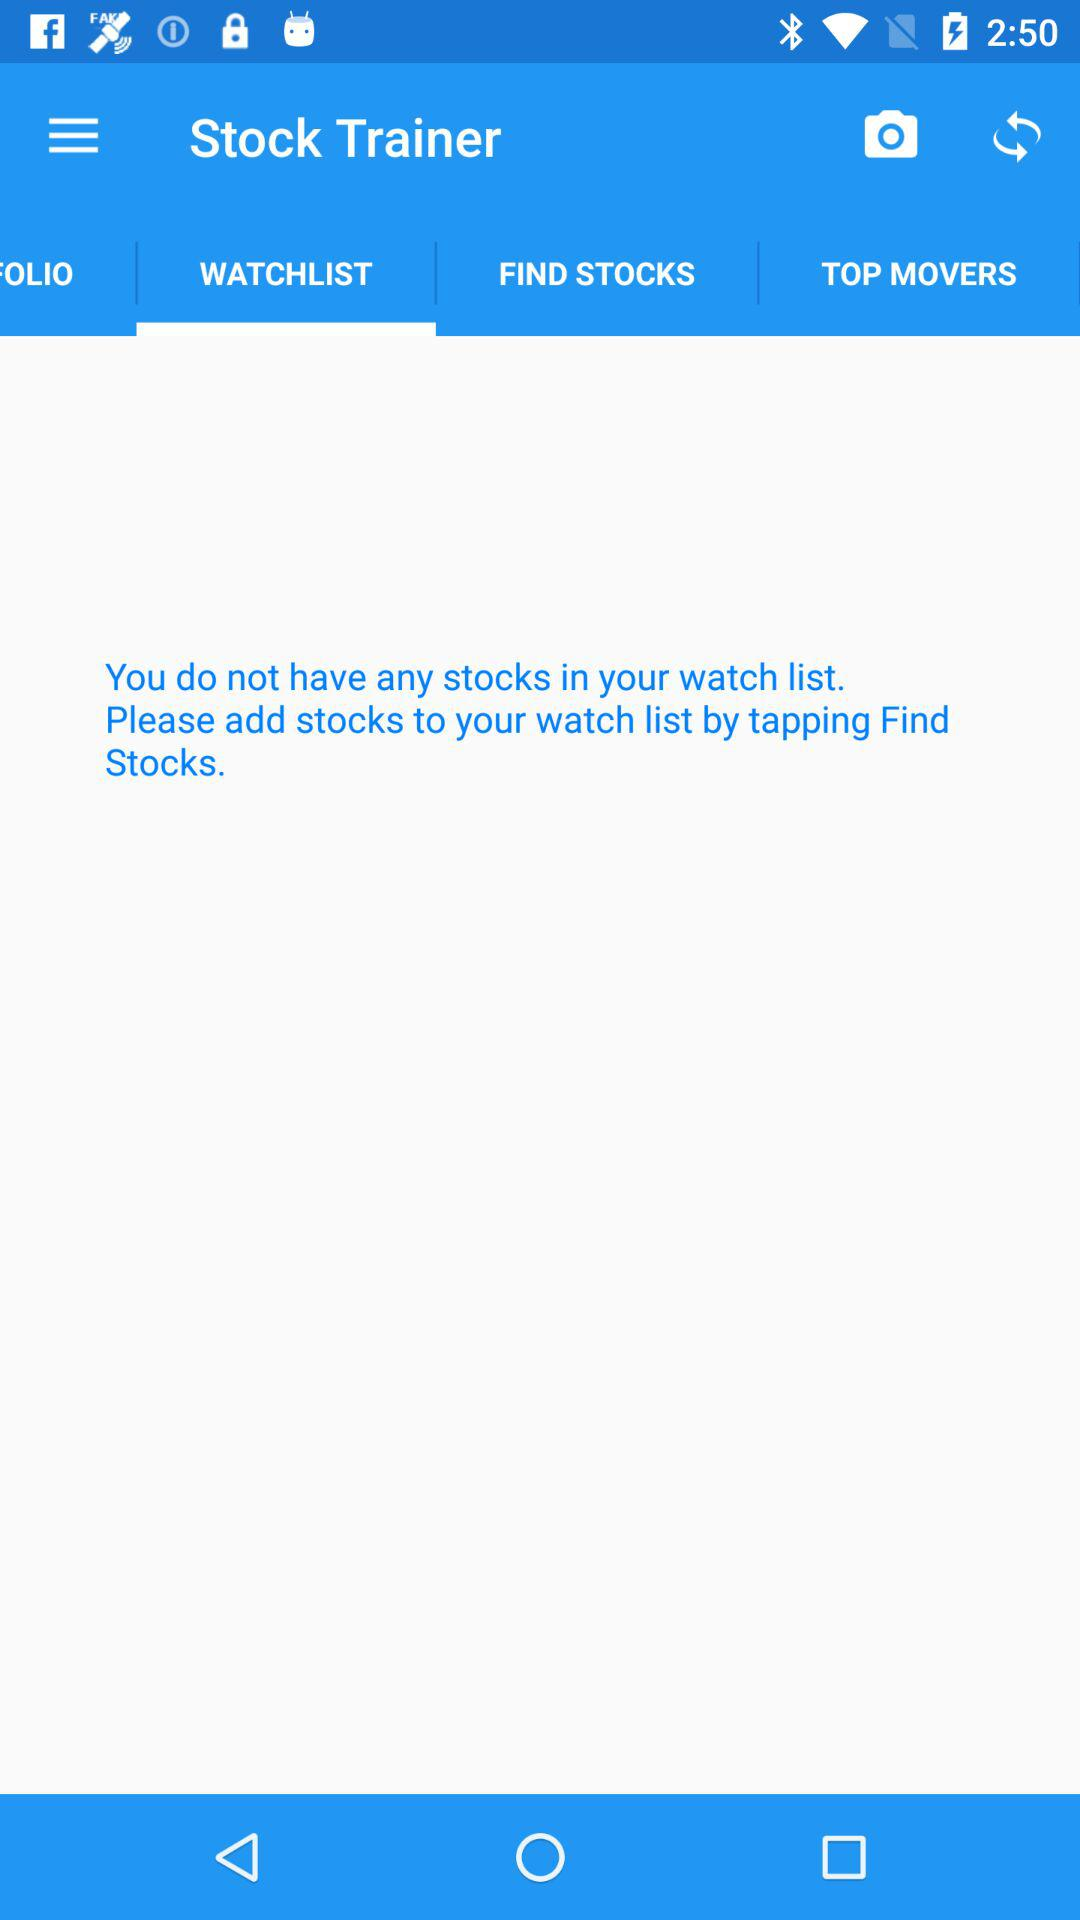What is the app name? The app name is "Stock Trainer". 